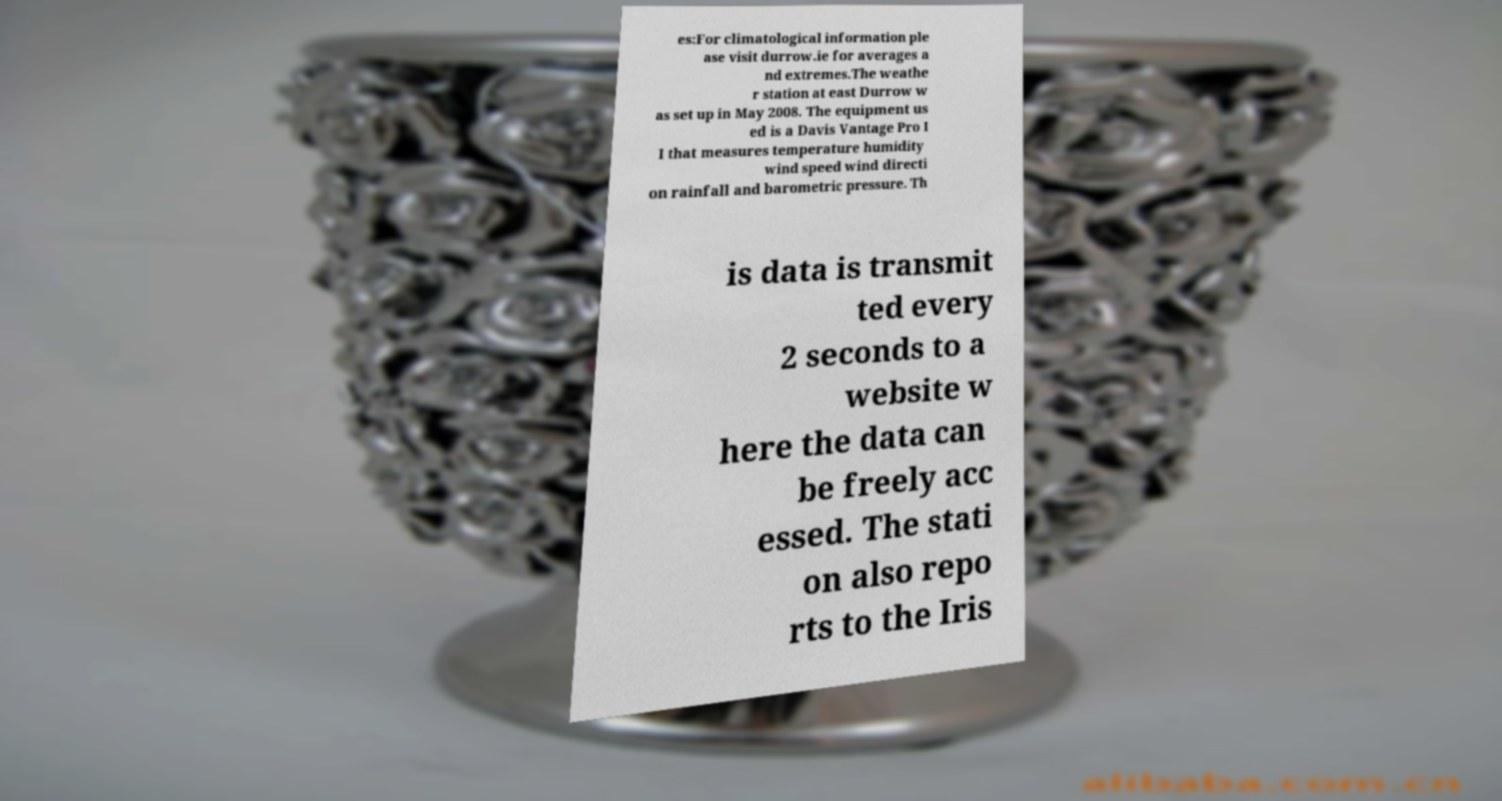Can you accurately transcribe the text from the provided image for me? es:For climatological information ple ase visit durrow.ie for averages a nd extremes.The weathe r station at east Durrow w as set up in May 2008. The equipment us ed is a Davis Vantage Pro I I that measures temperature humidity wind speed wind directi on rainfall and barometric pressure. Th is data is transmit ted every 2 seconds to a website w here the data can be freely acc essed. The stati on also repo rts to the Iris 